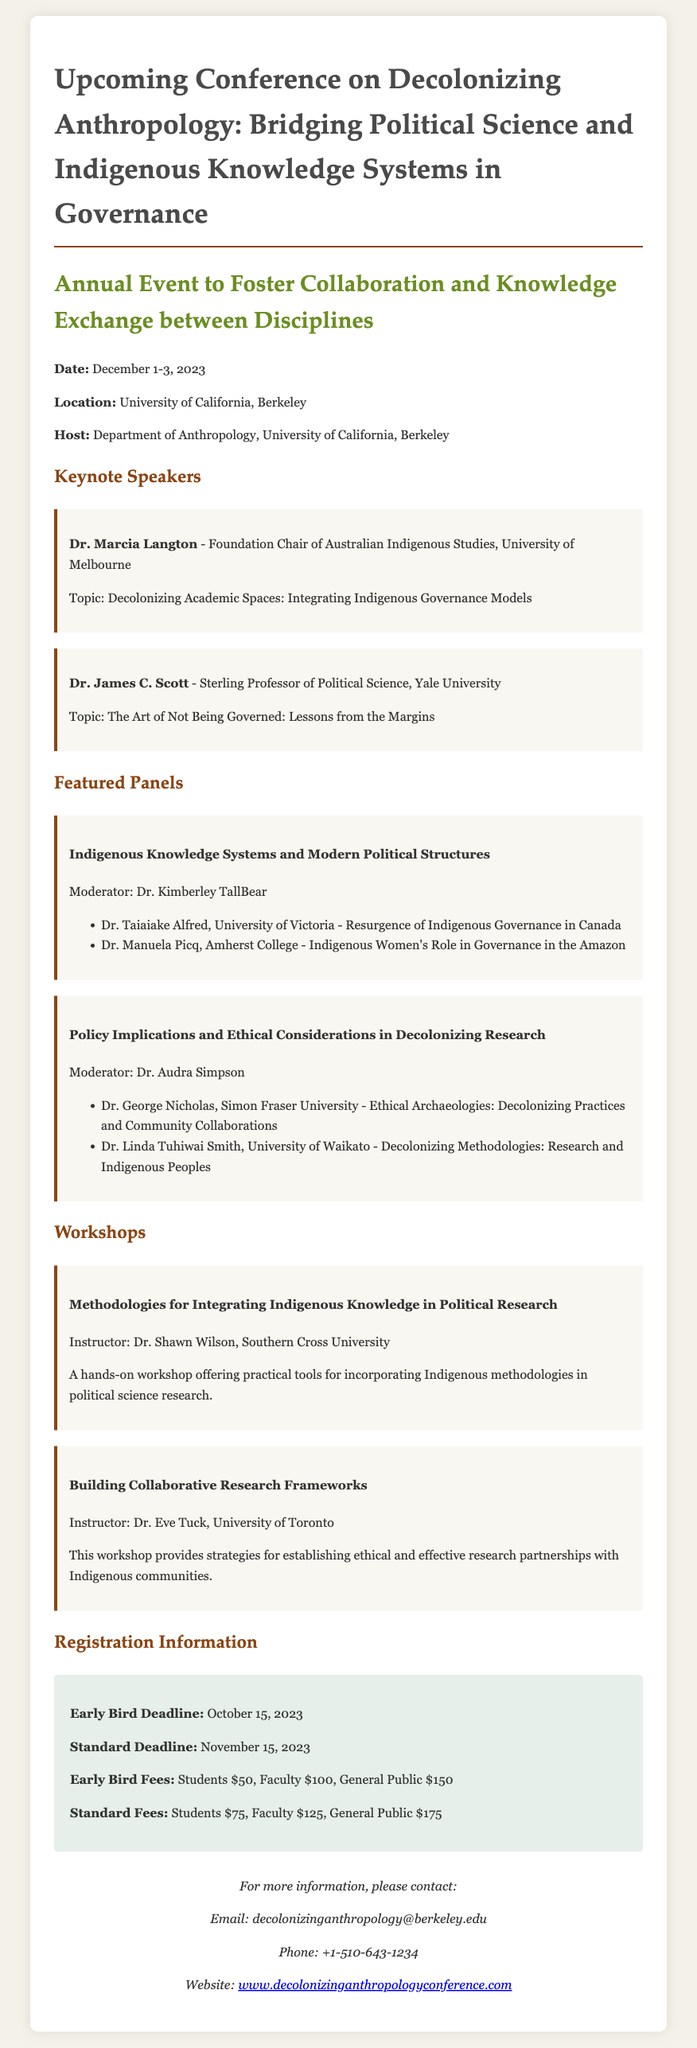What are the dates of the conference? The document states the conference will take place from December 1-3, 2023.
Answer: December 1-3, 2023 Who is the host of the conference? The host organization is mentioned in the document as the Department of Anthropology, University of California, Berkeley.
Answer: Department of Anthropology, University of California, Berkeley What is the early bird fee for students? The early bird fee for students is specifically listed in the registration section of the document.
Answer: $50 Who is moderating the panel on "Indigenous Knowledge Systems and Modern Political Structures"? The document indicates that Dr. Kimberley TallBear is the moderator for this panel.
Answer: Dr. Kimberley TallBear What is the main focus of Dr. Marcia Langton's keynote topic? The topic title mentioned for Dr. Marcia Langton addresses decolonizing academic spaces.
Answer: Decolonizing Academic Spaces: Integrating Indigenous Governance Models What workshop is offered by Dr. Eve Tuck? The document lists the workshop provided by Dr. Eve Tuck, highlighting both the name and instructor.
Answer: Building Collaborative Research Frameworks How many featured panels are listed in the document? The document explicitly outlines two featured panels under the relevant section.
Answer: Two What is the contact phone number for the conference? The document provides specific contact details, including a phone number for inquiries.
Answer: +1-510-643-1234 What is the website for more information about the conference? The document specifies a website for further details as part of the contact information.
Answer: www.decolonizinganthropologyconference.com 